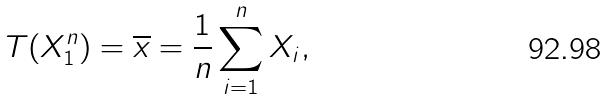<formula> <loc_0><loc_0><loc_500><loc_500>T ( X _ { 1 } ^ { n } ) = { \overline { x } } = { \frac { 1 } { n } } \sum _ { i = 1 } ^ { n } X _ { i } ,</formula> 